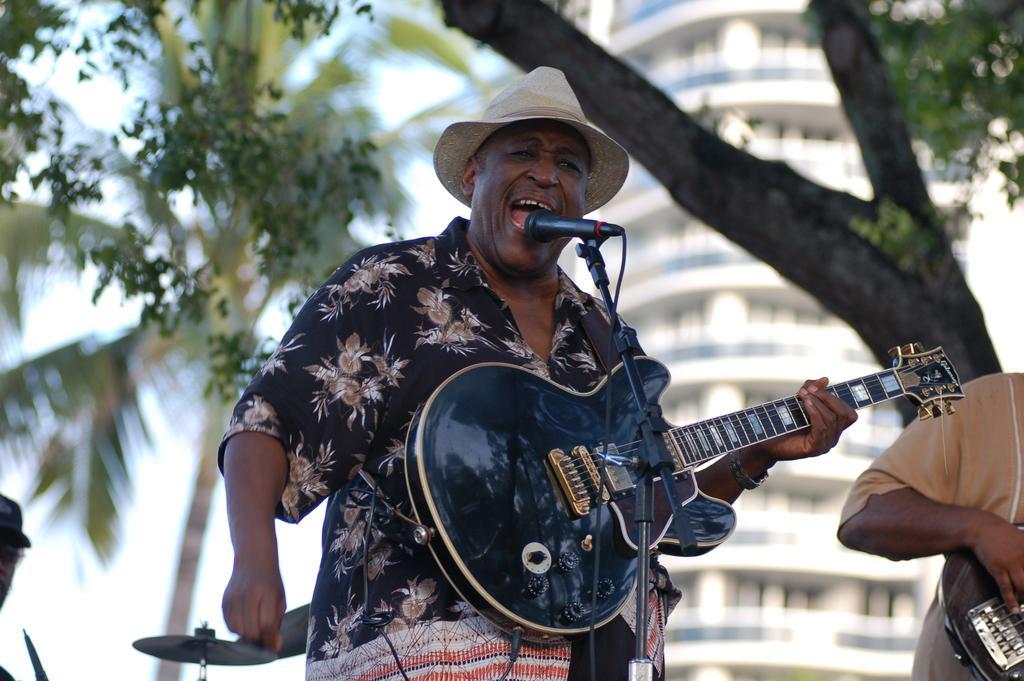How would you summarize this image in a sentence or two? In the image we can see there are people who are standing with a guitar in his hand. 